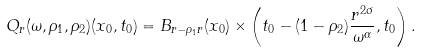Convert formula to latex. <formula><loc_0><loc_0><loc_500><loc_500>Q _ { r } ( \omega , \rho _ { 1 } , \rho _ { 2 } ) ( x _ { 0 } , t _ { 0 } ) = B _ { r - \rho _ { 1 } r } ( x _ { 0 } ) \times \left ( t _ { 0 } - ( 1 - \rho _ { 2 } ) \frac { r ^ { 2 \sigma } } { \omega ^ { \alpha } } , t _ { 0 } \right ) .</formula> 